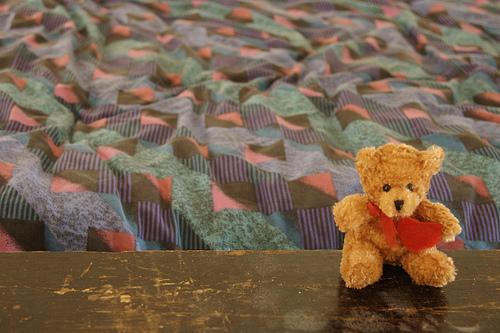What color is the heart?
Keep it brief. Red. How many people are in the picture?
Give a very brief answer. 0. Who flew that ship?
Write a very short answer. Bear. Is the shelf in new condition?
Give a very brief answer. No. 